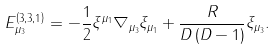<formula> <loc_0><loc_0><loc_500><loc_500>E _ { \mu _ { 3 } } ^ { \left ( 3 , 3 , 1 \right ) } = - \frac { 1 } { 2 } \xi ^ { \mu _ { 1 } } \nabla _ { \mu _ { 3 } } \xi _ { \mu _ { 1 } } + \frac { R } { D \left ( D - 1 \right ) } \xi _ { \mu _ { 3 } } .</formula> 